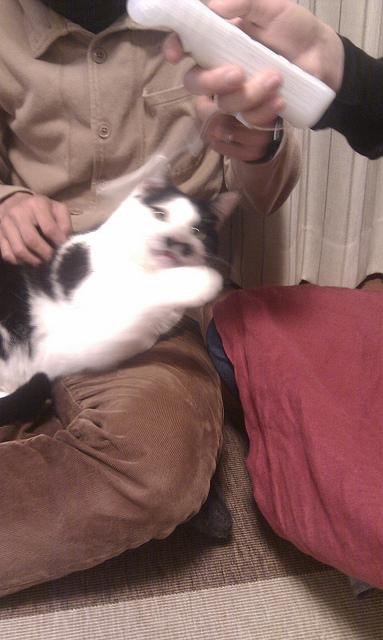What year was this video game console first released?

Choices:
A) 2006
B) 2021
C) 1999
D) 2012 2006 